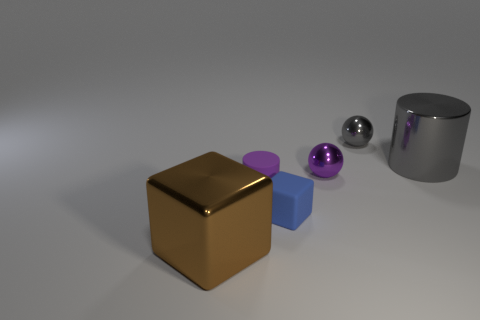How many metal things are either tiny gray spheres or gray objects?
Ensure brevity in your answer.  2. Is the small ball that is in front of the tiny gray metallic object made of the same material as the gray thing that is right of the gray metallic sphere?
Make the answer very short. Yes. Are any small gray rubber cubes visible?
Make the answer very short. No. There is a big thing right of the brown block; is its shape the same as the small metal thing that is in front of the tiny gray sphere?
Your response must be concise. No. Is there a tiny blue block that has the same material as the large gray thing?
Provide a short and direct response. No. Are the big thing that is on the left side of the gray metal ball and the small blue object made of the same material?
Keep it short and to the point. No. Is the number of tiny gray balls to the left of the metal cylinder greater than the number of purple spheres to the left of the tiny blue matte thing?
Provide a succinct answer. Yes. The cylinder that is the same size as the purple sphere is what color?
Give a very brief answer. Purple. Are there any tiny blocks of the same color as the rubber cylinder?
Give a very brief answer. No. There is a small shiny object in front of the large gray cylinder; is its color the same as the block that is left of the purple matte cylinder?
Offer a very short reply. No. 